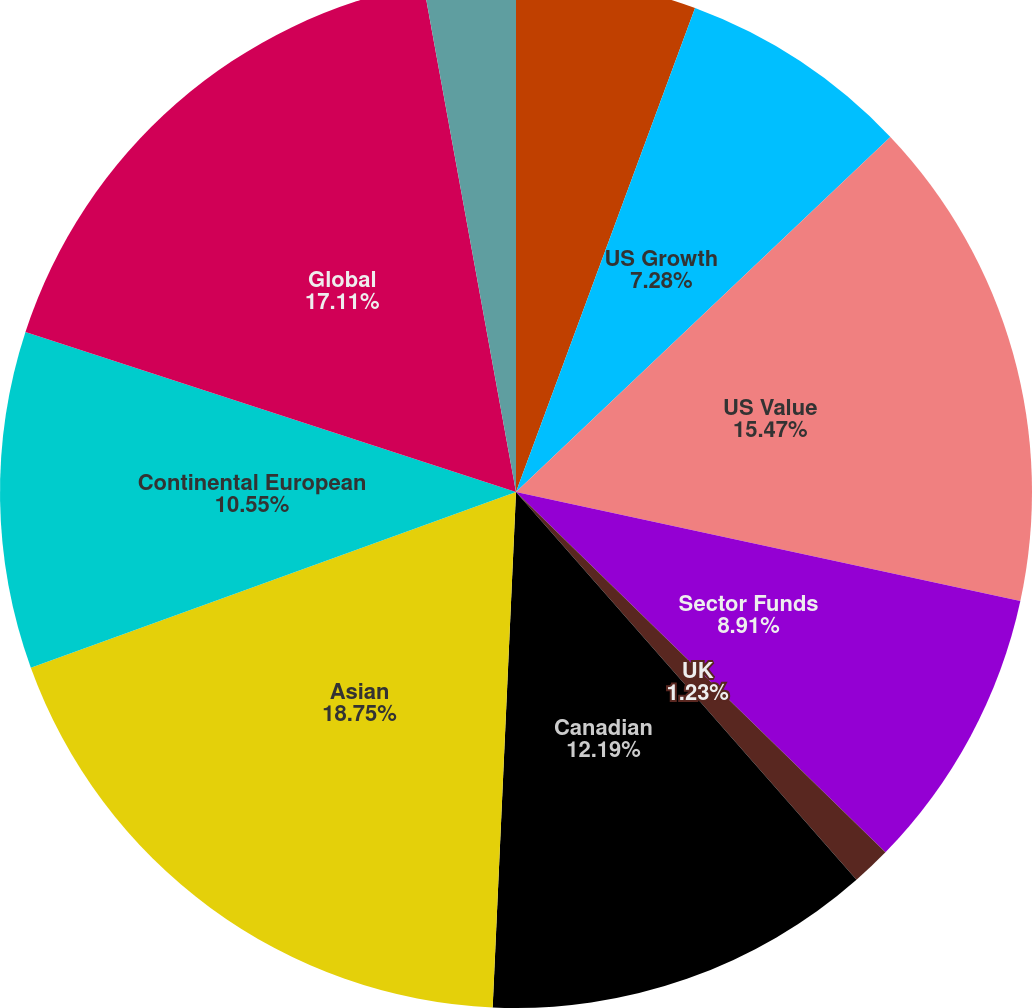Convert chart. <chart><loc_0><loc_0><loc_500><loc_500><pie_chart><fcel>US Core<fcel>US Growth<fcel>US Value<fcel>Sector Funds<fcel>UK<fcel>Canadian<fcel>Asian<fcel>Continental European<fcel>Global<fcel>Global Ex US and Emerging<nl><fcel>5.64%<fcel>7.28%<fcel>15.47%<fcel>8.91%<fcel>1.23%<fcel>12.19%<fcel>18.75%<fcel>10.55%<fcel>17.11%<fcel>2.87%<nl></chart> 